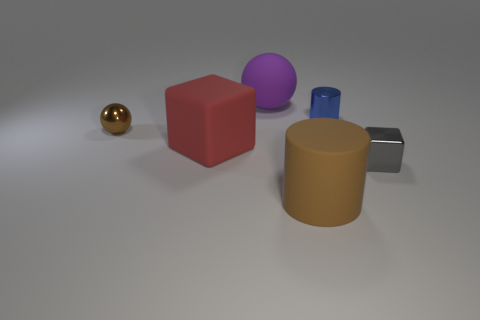Add 3 shiny balls. How many objects exist? 9 Subtract all spheres. How many objects are left? 4 Subtract all objects. Subtract all big purple cubes. How many objects are left? 0 Add 3 brown cylinders. How many brown cylinders are left? 4 Add 3 purple rubber objects. How many purple rubber objects exist? 4 Subtract 0 green cylinders. How many objects are left? 6 